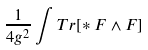Convert formula to latex. <formula><loc_0><loc_0><loc_500><loc_500>\frac { 1 } { 4 g ^ { 2 } } \int T r [ * F \wedge F ]</formula> 